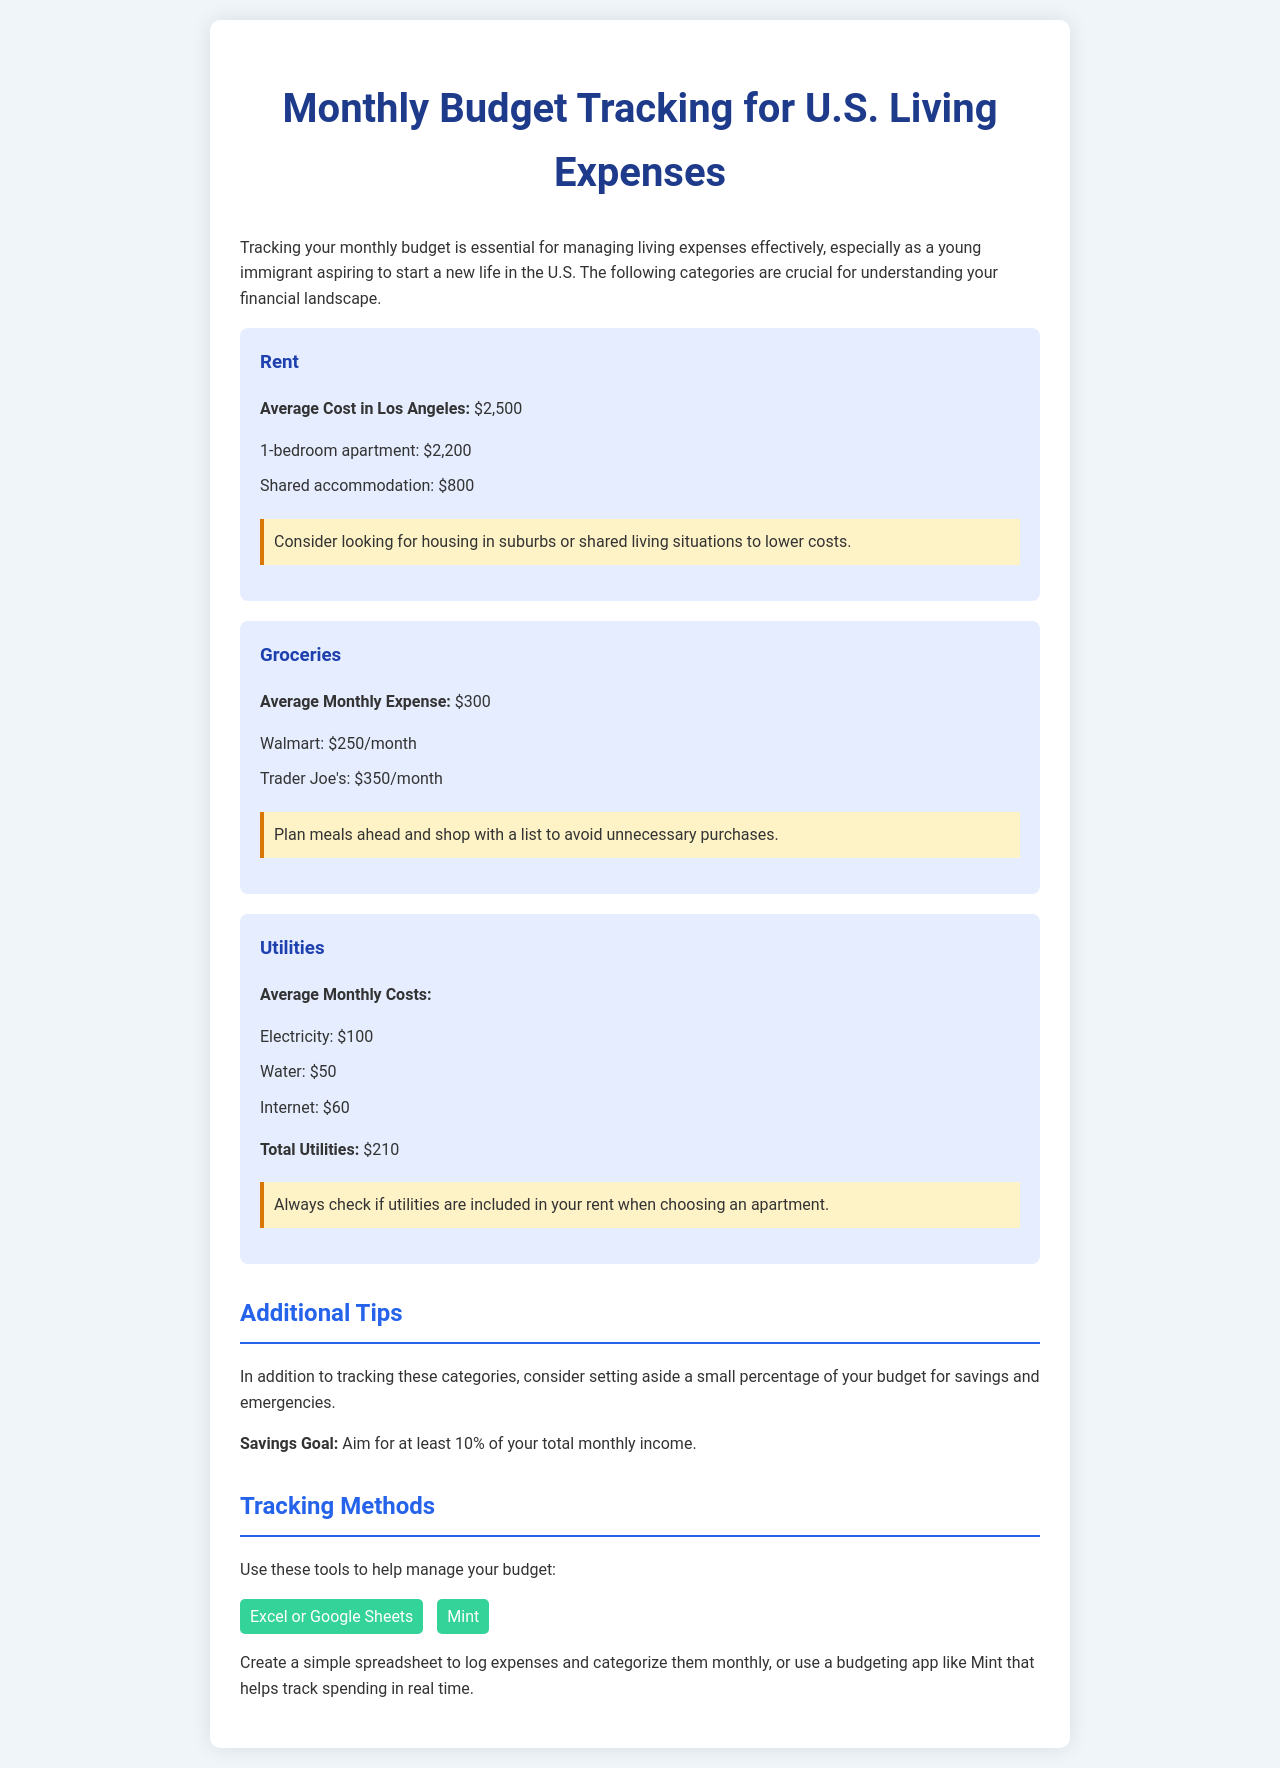What is the average cost of rent in Los Angeles? The document states that the average cost of rent in Los Angeles is $2,500.
Answer: $2,500 What is the monthly expense for groceries? The document mentions that the average monthly expense for groceries is $300.
Answer: $300 What is the total utilities cost? The document lists the total utilities cost as $210, which is the sum of electricity, water, and internet.
Answer: $210 How much is a 1-bedroom apartment? The document specifies that a 1-bedroom apartment costs $2,200.
Answer: $2,200 What percentage of total monthly income does the savings goal recommend? The document suggests aiming for at least 10% of your total monthly income for savings.
Answer: 10% What are two suggested tools for tracking a budget? The document lists Excel or Google Sheets and Mint as suggested tools for budget tracking.
Answer: Excel or Google Sheets, Mint What is a suggested way to lower housing costs? The document recommends looking for housing in suburbs or shared living situations to lower costs.
Answer: Shared living situations How much do groceries cost at Trader Joe's? The document indicates that groceries at Trader Joe's cost $350/month.
Answer: $350 What is the average monthly expense at Walmart for groceries? The document states that groceries at Walmart cost $250/month.
Answer: $250 